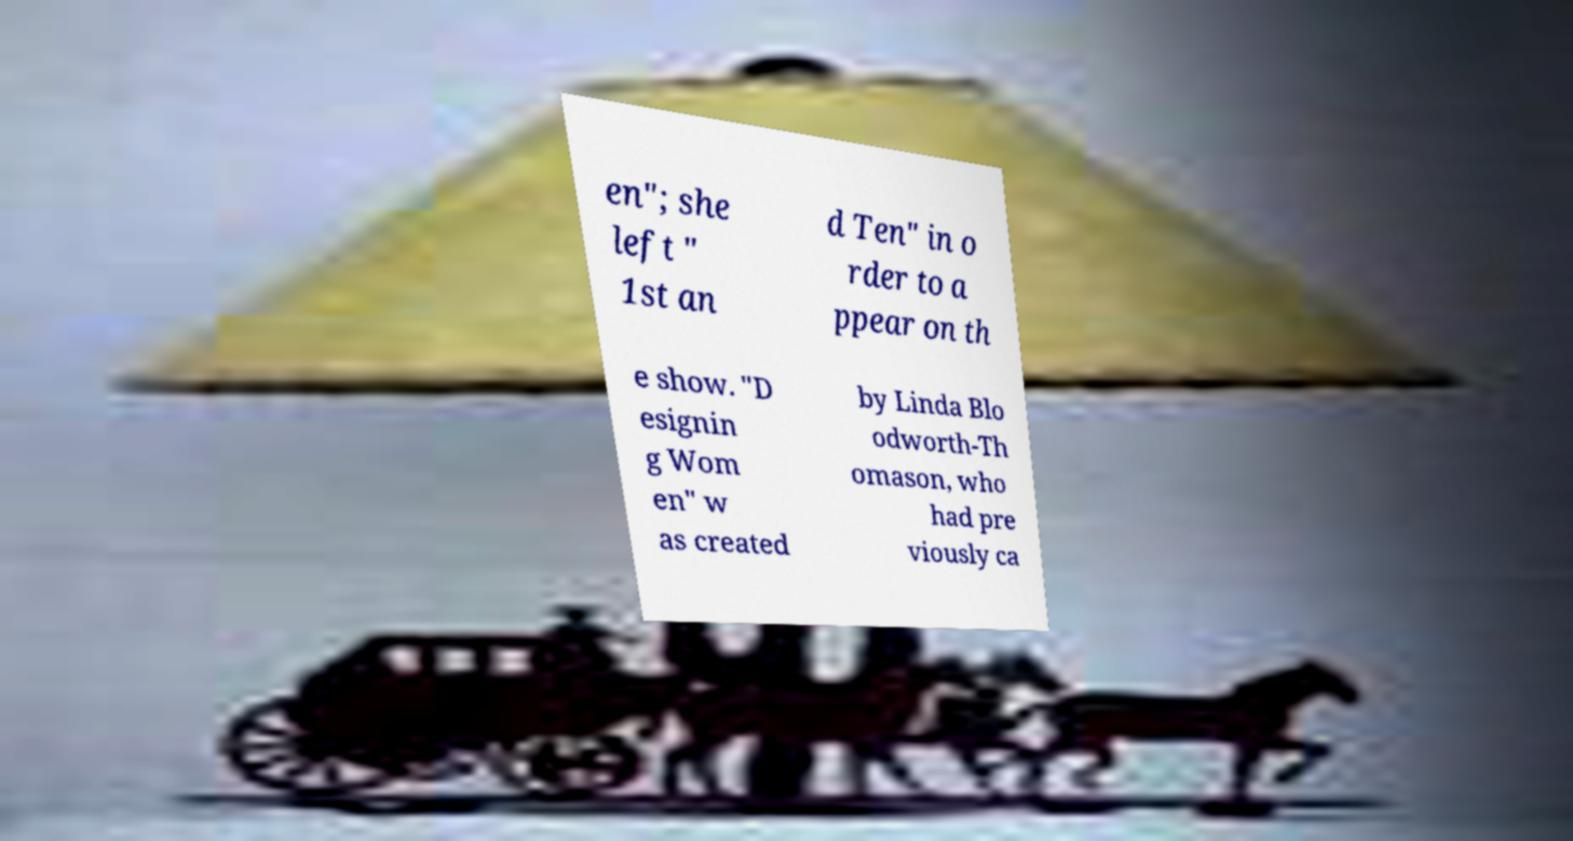For documentation purposes, I need the text within this image transcribed. Could you provide that? en"; she left " 1st an d Ten" in o rder to a ppear on th e show. "D esignin g Wom en" w as created by Linda Blo odworth-Th omason, who had pre viously ca 